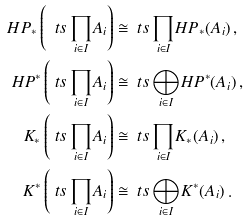Convert formula to latex. <formula><loc_0><loc_0><loc_500><loc_500>H P _ { * } \left ( { \ t s \prod _ { i \in I } } A _ { i } \right ) & \cong { \ t s \prod _ { i \in I } } H P _ { * } ( A _ { i } ) \, , \\ H P ^ { * } \left ( { \ t s \prod _ { i \in I } } A _ { i } \right ) & \cong { \ t s \bigoplus _ { i \in I } } H P ^ { * } ( A _ { i } ) \, , \\ K _ { * } \left ( { \ t s \prod _ { i \in I } } A _ { i } \right ) & \cong { \ t s \prod _ { i \in I } } K _ { * } ( A _ { i } ) \, , \\ K ^ { * } \left ( { \ t s \prod _ { i \in I } } A _ { i } \right ) & \cong { \ t s \bigoplus _ { i \in I } } K ^ { * } ( A _ { i } ) \, .</formula> 